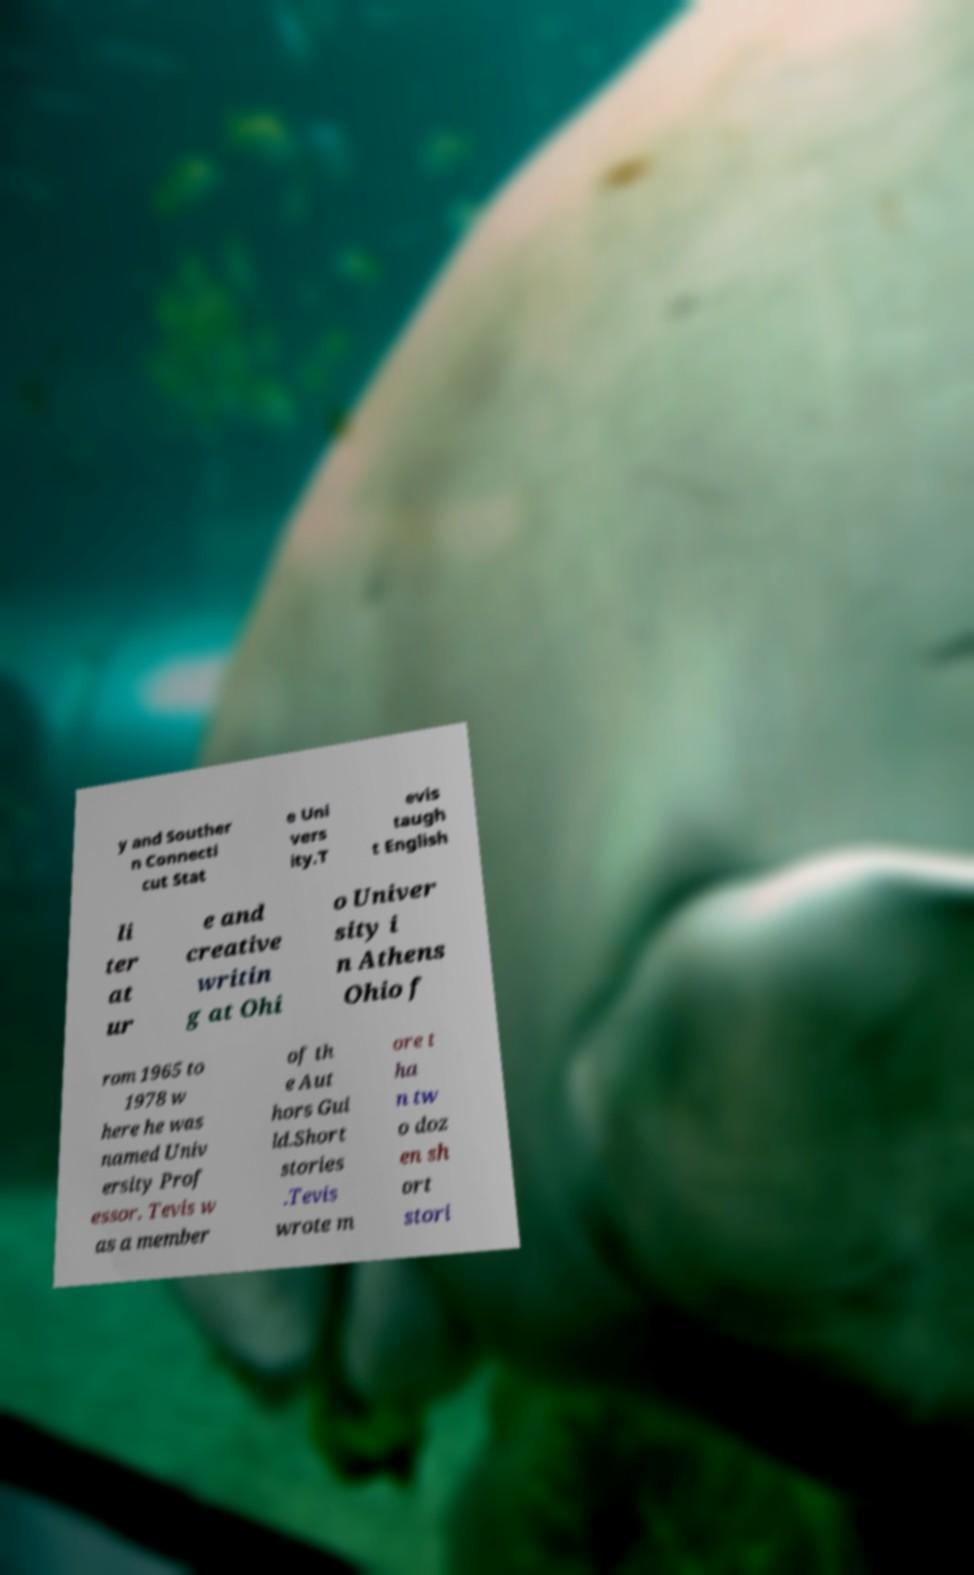For documentation purposes, I need the text within this image transcribed. Could you provide that? y and Souther n Connecti cut Stat e Uni vers ity.T evis taugh t English li ter at ur e and creative writin g at Ohi o Univer sity i n Athens Ohio f rom 1965 to 1978 w here he was named Univ ersity Prof essor. Tevis w as a member of th e Aut hors Gui ld.Short stories .Tevis wrote m ore t ha n tw o doz en sh ort stori 